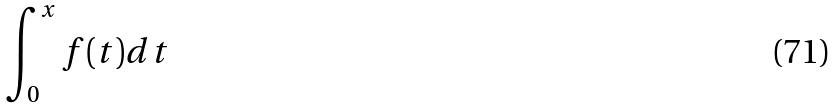Convert formula to latex. <formula><loc_0><loc_0><loc_500><loc_500>\int _ { 0 } ^ { x } f ( t ) d t</formula> 